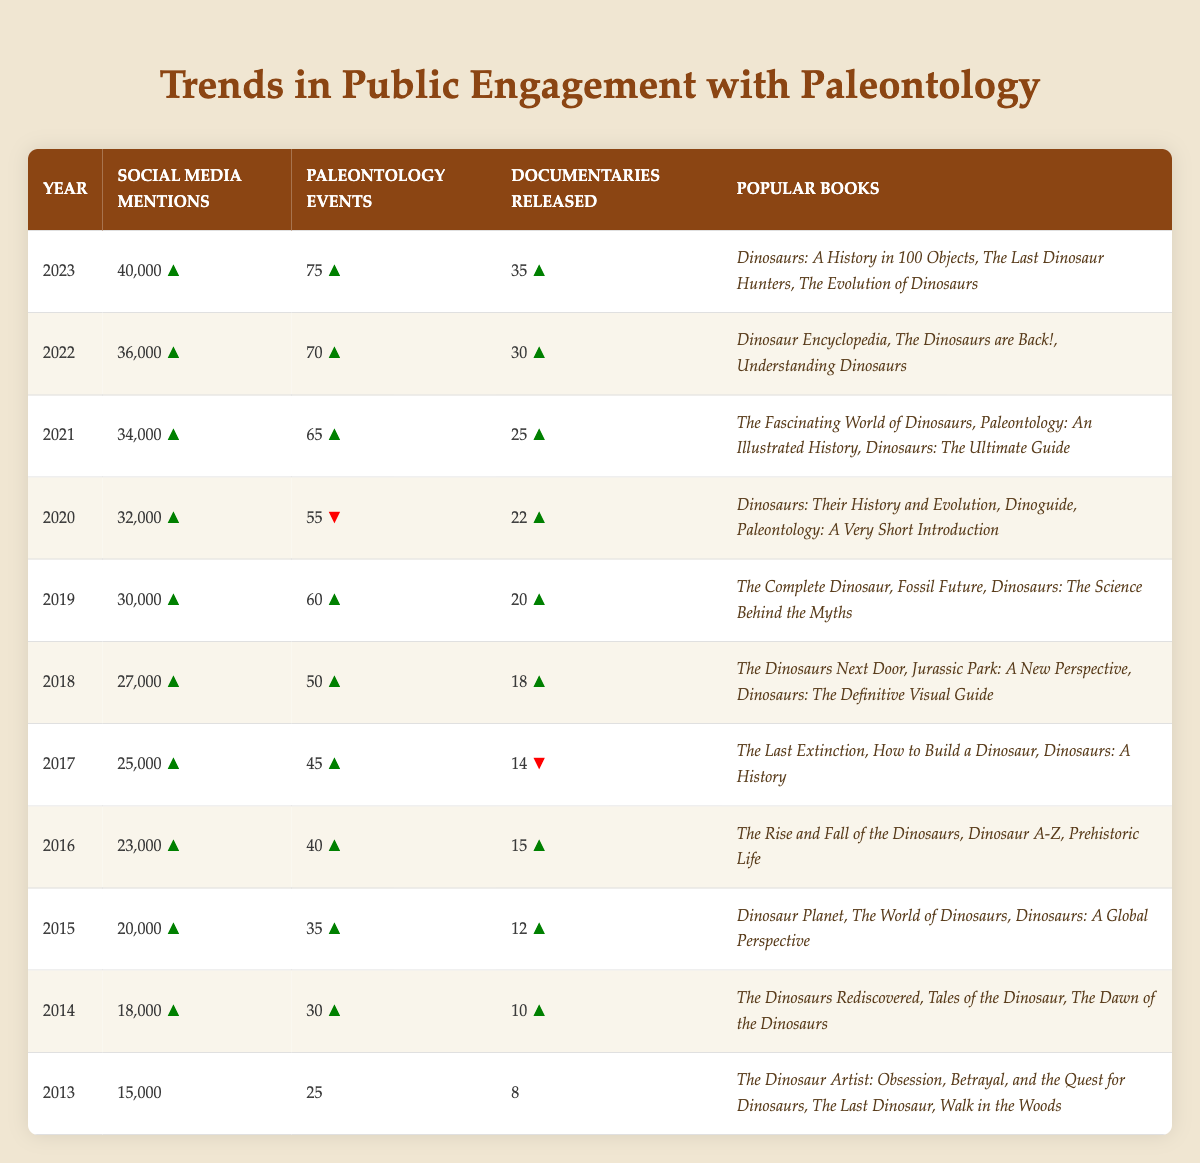What was the year with the highest number of social media mentions? Looking at the "Social Media Mentions" column in the table, the highest value is found in the year 2023 with 40,000 mentions.
Answer: 2023 How many documentaries were released in 2016? Referring to the "Documentaries Released" column for the year 2016, the value listed is 15.
Answer: 15 Which year saw a decrease in paleontology events compared to the previous year? Comparing the "Paleontology Events" column, the year 2020 shows a decrease to 55 events from 65 events in 2021.
Answer: 2020 What is the total number of documentaries released from 2013 to 2023? Summing the "Documentaries Released" for each year: 8 + 10 + 12 + 15 + 14 + 18 + 20 + 22 + 25 + 30 + 35 =  8 + 10 + 12 + 15 + 14 + 18 + 20 + 22 + 25 + 30 + 35 =  8 + 10 = 18, 18 + 12 = 30, 30 + 15 = 45, 45 + 14 = 59, 59 + 18 = 77, 77 + 20 = 97, 97 + 22 = 119, 119 + 25 = 144, 144 + 30 = 174, 174 + 35 = 209.
Answer: 209 In which year did the largest increase in social media mentions occur from the previous year? Examining the "Social Media Mentions," the largest increase is from 2019 (30,000) to 2020 (32,000), which represents an increase of 2,000. By checking year to year, it is confirmed this is the greatest upward change compared to all others.
Answer: 2020 Was there a year where the number of documentaries released was the same as the number of paleontology events? Looking through both the "Documentaries Released" and "Paleontology Events" columns, there are no instances where the values match; hence the answer is no.
Answer: No What is the average number of social media mentions from 2013 to 2023? To find the average, sum the social media mentions for each year: (15,000 + 18,000 + 20,000 + 23,000 + 25,000 + 27,000 + 30,000 + 32,000 + 34,000 + 36,000 + 40,000) =  15,000 + 18,000 + 20,000 + 23,000 + 25,000 + 27,000 + 30,000 + 32,000 + 34,000 + 36,000 + 40,000 =  15,000 + 18,000 = 33,000, 33,000 + 20,000 = 53,000, 53,000 + 23,000 = 76,000, 76,000 + 25,000 = 101,000, 101,000 + 27,000 = 128,000, 128,000 + 30,000 = 158,000, 158,000 + 32,000 = 190,000, 190,000 + 34,000 = 224,000, 224,000 + 36,000 = 260,000, 260,000 + 40,000 = 300,000. There are 11 data points, so the average is 300,000 / 11 = 27,273.
Answer: 27,273 Which year had the highest number of popular books listed? The year 2023 has 3 popular books listed under it, while all other years also have 3; however, 2023 continues the trend and is the last year, indicating ongoing popularity.
Answer: 2023 